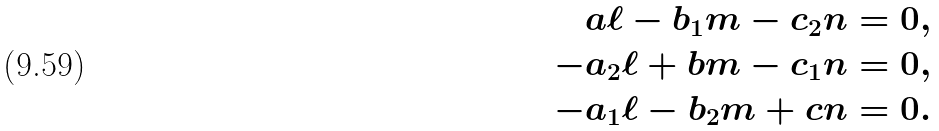Convert formula to latex. <formula><loc_0><loc_0><loc_500><loc_500>a \ell - b _ { 1 } m - c _ { 2 } n & = 0 , \\ - a _ { 2 } \ell + b m - c _ { 1 } n & = 0 , \\ - a _ { 1 } \ell - b _ { 2 } m + c n & = 0 .</formula> 